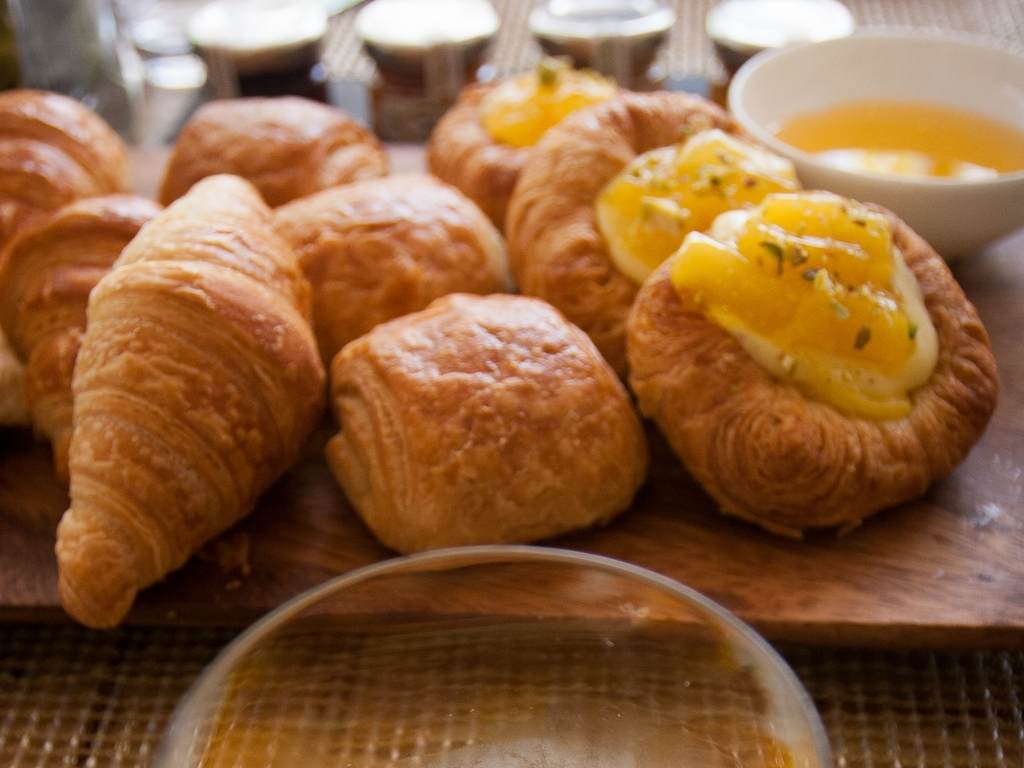What is the quality of this picture? The quality of the image is below average due to noticeable blurriness and lack of sharpness, which affects the detail and textures of the croissants and pastries, diminishing the viewer's ability to fully appreciate the colors and features of the food. 